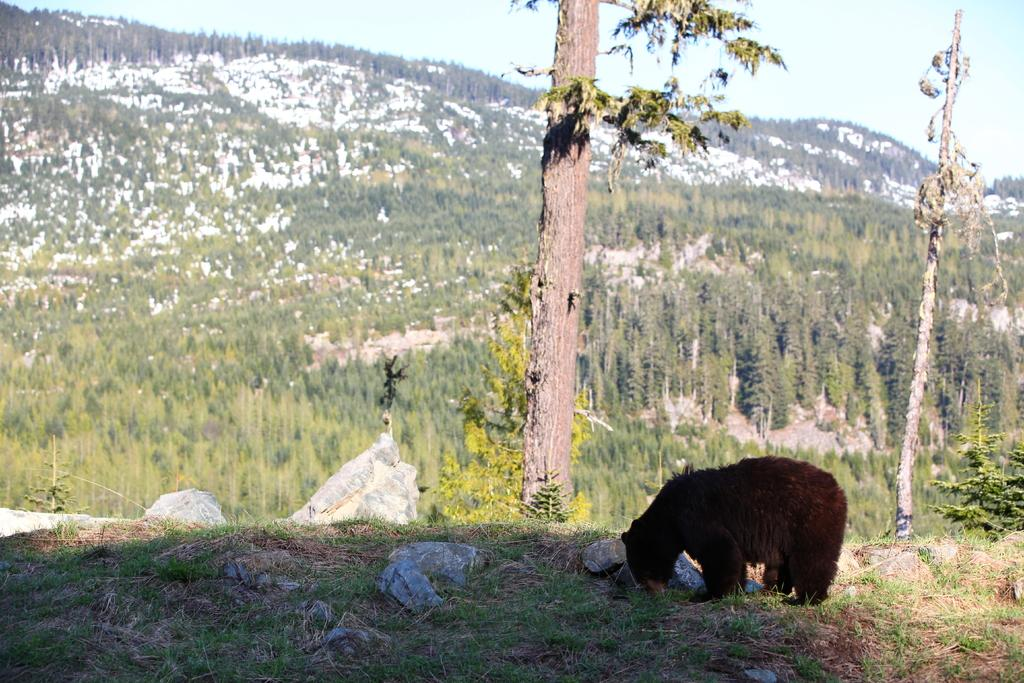What type of animal is at the bottom of the image? There is an animal at the bottom of the image, but the specific type cannot be determined from the facts provided. What type of vegetation is present in the image? There is grass in the image. What can be seen in the background of the image? There are trees, rocks, hills, and the sky visible in the background of the image. How many snails are crawling on the card in the image? There is no card or snails present in the image. What type of kick is being performed by the animal in the image? There is no kick being performed by the animal in the image, as it is not mentioned in the facts provided. 